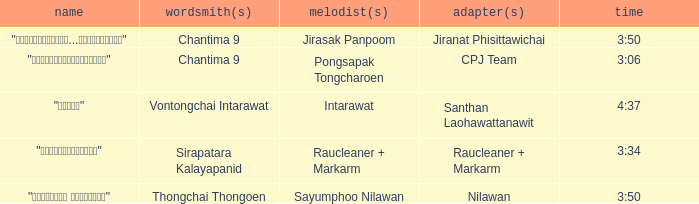Who was the composer of "ขอโทษ"? Intarawat. 